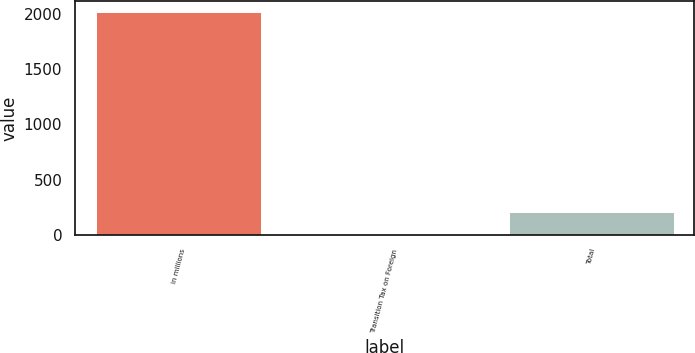<chart> <loc_0><loc_0><loc_500><loc_500><bar_chart><fcel>in millions<fcel>Transition Tax on Foreign<fcel>Total<nl><fcel>2018<fcel>5<fcel>206.3<nl></chart> 